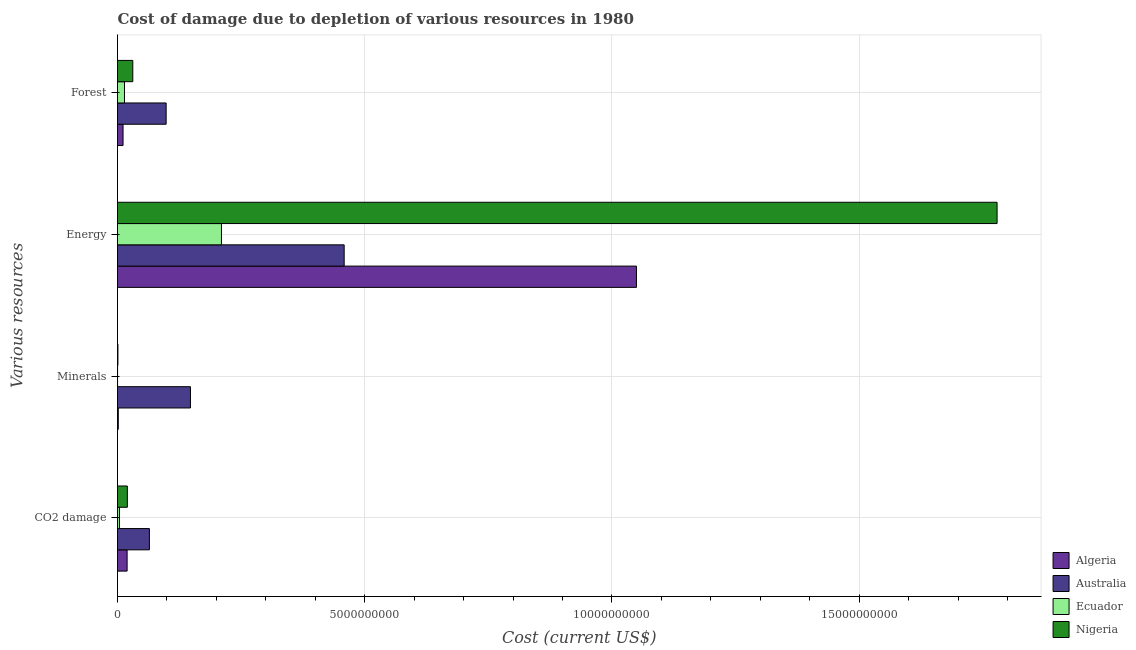How many bars are there on the 3rd tick from the bottom?
Offer a very short reply. 4. What is the label of the 2nd group of bars from the top?
Offer a very short reply. Energy. What is the cost of damage due to depletion of forests in Nigeria?
Keep it short and to the point. 3.09e+08. Across all countries, what is the maximum cost of damage due to depletion of forests?
Your answer should be very brief. 9.84e+08. Across all countries, what is the minimum cost of damage due to depletion of minerals?
Your response must be concise. 1.04e+06. In which country was the cost of damage due to depletion of energy maximum?
Ensure brevity in your answer.  Nigeria. In which country was the cost of damage due to depletion of energy minimum?
Give a very brief answer. Ecuador. What is the total cost of damage due to depletion of minerals in the graph?
Offer a very short reply. 1.50e+09. What is the difference between the cost of damage due to depletion of energy in Ecuador and that in Nigeria?
Your response must be concise. -1.57e+1. What is the difference between the cost of damage due to depletion of forests in Ecuador and the cost of damage due to depletion of minerals in Nigeria?
Provide a succinct answer. 1.33e+08. What is the average cost of damage due to depletion of minerals per country?
Ensure brevity in your answer.  3.75e+08. What is the difference between the cost of damage due to depletion of minerals and cost of damage due to depletion of energy in Nigeria?
Provide a succinct answer. -1.78e+1. What is the ratio of the cost of damage due to depletion of forests in Algeria to that in Ecuador?
Ensure brevity in your answer.  0.79. What is the difference between the highest and the second highest cost of damage due to depletion of forests?
Your answer should be compact. 6.75e+08. What is the difference between the highest and the lowest cost of damage due to depletion of forests?
Make the answer very short. 8.72e+08. Is it the case that in every country, the sum of the cost of damage due to depletion of forests and cost of damage due to depletion of energy is greater than the sum of cost of damage due to depletion of minerals and cost of damage due to depletion of coal?
Provide a short and direct response. No. What does the 2nd bar from the top in Forest represents?
Your answer should be compact. Ecuador. What does the 3rd bar from the bottom in Forest represents?
Provide a succinct answer. Ecuador. Is it the case that in every country, the sum of the cost of damage due to depletion of coal and cost of damage due to depletion of minerals is greater than the cost of damage due to depletion of energy?
Keep it short and to the point. No. Are all the bars in the graph horizontal?
Your answer should be compact. Yes. What is the difference between two consecutive major ticks on the X-axis?
Give a very brief answer. 5.00e+09. Are the values on the major ticks of X-axis written in scientific E-notation?
Ensure brevity in your answer.  No. Where does the legend appear in the graph?
Your answer should be very brief. Bottom right. How are the legend labels stacked?
Your response must be concise. Vertical. What is the title of the graph?
Offer a very short reply. Cost of damage due to depletion of various resources in 1980 . What is the label or title of the X-axis?
Provide a succinct answer. Cost (current US$). What is the label or title of the Y-axis?
Offer a terse response. Various resources. What is the Cost (current US$) in Algeria in CO2 damage?
Your answer should be very brief. 1.94e+08. What is the Cost (current US$) in Australia in CO2 damage?
Your answer should be very brief. 6.45e+08. What is the Cost (current US$) of Ecuador in CO2 damage?
Provide a short and direct response. 3.93e+07. What is the Cost (current US$) in Nigeria in CO2 damage?
Provide a succinct answer. 1.99e+08. What is the Cost (current US$) in Algeria in Minerals?
Provide a short and direct response. 1.57e+07. What is the Cost (current US$) of Australia in Minerals?
Provide a succinct answer. 1.48e+09. What is the Cost (current US$) of Ecuador in Minerals?
Ensure brevity in your answer.  1.04e+06. What is the Cost (current US$) in Nigeria in Minerals?
Your answer should be very brief. 8.49e+06. What is the Cost (current US$) of Algeria in Energy?
Your answer should be very brief. 1.05e+1. What is the Cost (current US$) in Australia in Energy?
Provide a short and direct response. 4.58e+09. What is the Cost (current US$) in Ecuador in Energy?
Your answer should be very brief. 2.10e+09. What is the Cost (current US$) in Nigeria in Energy?
Provide a succinct answer. 1.78e+1. What is the Cost (current US$) of Algeria in Forest?
Your answer should be very brief. 1.12e+08. What is the Cost (current US$) in Australia in Forest?
Ensure brevity in your answer.  9.84e+08. What is the Cost (current US$) of Ecuador in Forest?
Provide a short and direct response. 1.41e+08. What is the Cost (current US$) of Nigeria in Forest?
Provide a short and direct response. 3.09e+08. Across all Various resources, what is the maximum Cost (current US$) in Algeria?
Your answer should be compact. 1.05e+1. Across all Various resources, what is the maximum Cost (current US$) of Australia?
Offer a terse response. 4.58e+09. Across all Various resources, what is the maximum Cost (current US$) in Ecuador?
Keep it short and to the point. 2.10e+09. Across all Various resources, what is the maximum Cost (current US$) in Nigeria?
Your answer should be compact. 1.78e+1. Across all Various resources, what is the minimum Cost (current US$) in Algeria?
Keep it short and to the point. 1.57e+07. Across all Various resources, what is the minimum Cost (current US$) of Australia?
Ensure brevity in your answer.  6.45e+08. Across all Various resources, what is the minimum Cost (current US$) of Ecuador?
Your answer should be very brief. 1.04e+06. Across all Various resources, what is the minimum Cost (current US$) in Nigeria?
Provide a short and direct response. 8.49e+06. What is the total Cost (current US$) of Algeria in the graph?
Your answer should be compact. 1.08e+1. What is the total Cost (current US$) of Australia in the graph?
Offer a very short reply. 7.69e+09. What is the total Cost (current US$) in Ecuador in the graph?
Make the answer very short. 2.28e+09. What is the total Cost (current US$) of Nigeria in the graph?
Ensure brevity in your answer.  1.83e+1. What is the difference between the Cost (current US$) of Algeria in CO2 damage and that in Minerals?
Make the answer very short. 1.79e+08. What is the difference between the Cost (current US$) of Australia in CO2 damage and that in Minerals?
Your answer should be compact. -8.30e+08. What is the difference between the Cost (current US$) in Ecuador in CO2 damage and that in Minerals?
Offer a terse response. 3.82e+07. What is the difference between the Cost (current US$) in Nigeria in CO2 damage and that in Minerals?
Provide a short and direct response. 1.91e+08. What is the difference between the Cost (current US$) in Algeria in CO2 damage and that in Energy?
Ensure brevity in your answer.  -1.03e+1. What is the difference between the Cost (current US$) of Australia in CO2 damage and that in Energy?
Your answer should be very brief. -3.94e+09. What is the difference between the Cost (current US$) in Ecuador in CO2 damage and that in Energy?
Offer a terse response. -2.06e+09. What is the difference between the Cost (current US$) in Nigeria in CO2 damage and that in Energy?
Offer a very short reply. -1.76e+1. What is the difference between the Cost (current US$) of Algeria in CO2 damage and that in Forest?
Ensure brevity in your answer.  8.23e+07. What is the difference between the Cost (current US$) of Australia in CO2 damage and that in Forest?
Offer a very short reply. -3.39e+08. What is the difference between the Cost (current US$) in Ecuador in CO2 damage and that in Forest?
Give a very brief answer. -1.02e+08. What is the difference between the Cost (current US$) of Nigeria in CO2 damage and that in Forest?
Keep it short and to the point. -1.10e+08. What is the difference between the Cost (current US$) of Algeria in Minerals and that in Energy?
Offer a terse response. -1.05e+1. What is the difference between the Cost (current US$) in Australia in Minerals and that in Energy?
Ensure brevity in your answer.  -3.11e+09. What is the difference between the Cost (current US$) of Ecuador in Minerals and that in Energy?
Keep it short and to the point. -2.10e+09. What is the difference between the Cost (current US$) of Nigeria in Minerals and that in Energy?
Keep it short and to the point. -1.78e+1. What is the difference between the Cost (current US$) in Algeria in Minerals and that in Forest?
Provide a succinct answer. -9.63e+07. What is the difference between the Cost (current US$) in Australia in Minerals and that in Forest?
Provide a succinct answer. 4.92e+08. What is the difference between the Cost (current US$) in Ecuador in Minerals and that in Forest?
Provide a short and direct response. -1.40e+08. What is the difference between the Cost (current US$) of Nigeria in Minerals and that in Forest?
Your response must be concise. -3.01e+08. What is the difference between the Cost (current US$) in Algeria in Energy and that in Forest?
Keep it short and to the point. 1.04e+1. What is the difference between the Cost (current US$) of Australia in Energy and that in Forest?
Keep it short and to the point. 3.60e+09. What is the difference between the Cost (current US$) of Ecuador in Energy and that in Forest?
Provide a succinct answer. 1.96e+09. What is the difference between the Cost (current US$) of Nigeria in Energy and that in Forest?
Your response must be concise. 1.75e+1. What is the difference between the Cost (current US$) in Algeria in CO2 damage and the Cost (current US$) in Australia in Minerals?
Your answer should be very brief. -1.28e+09. What is the difference between the Cost (current US$) of Algeria in CO2 damage and the Cost (current US$) of Ecuador in Minerals?
Offer a terse response. 1.93e+08. What is the difference between the Cost (current US$) of Algeria in CO2 damage and the Cost (current US$) of Nigeria in Minerals?
Keep it short and to the point. 1.86e+08. What is the difference between the Cost (current US$) of Australia in CO2 damage and the Cost (current US$) of Ecuador in Minerals?
Provide a short and direct response. 6.44e+08. What is the difference between the Cost (current US$) in Australia in CO2 damage and the Cost (current US$) in Nigeria in Minerals?
Ensure brevity in your answer.  6.37e+08. What is the difference between the Cost (current US$) in Ecuador in CO2 damage and the Cost (current US$) in Nigeria in Minerals?
Your answer should be very brief. 3.08e+07. What is the difference between the Cost (current US$) of Algeria in CO2 damage and the Cost (current US$) of Australia in Energy?
Offer a very short reply. -4.39e+09. What is the difference between the Cost (current US$) in Algeria in CO2 damage and the Cost (current US$) in Ecuador in Energy?
Make the answer very short. -1.91e+09. What is the difference between the Cost (current US$) in Algeria in CO2 damage and the Cost (current US$) in Nigeria in Energy?
Your response must be concise. -1.76e+1. What is the difference between the Cost (current US$) of Australia in CO2 damage and the Cost (current US$) of Ecuador in Energy?
Provide a short and direct response. -1.46e+09. What is the difference between the Cost (current US$) in Australia in CO2 damage and the Cost (current US$) in Nigeria in Energy?
Provide a succinct answer. -1.71e+1. What is the difference between the Cost (current US$) of Ecuador in CO2 damage and the Cost (current US$) of Nigeria in Energy?
Make the answer very short. -1.77e+1. What is the difference between the Cost (current US$) in Algeria in CO2 damage and the Cost (current US$) in Australia in Forest?
Your response must be concise. -7.89e+08. What is the difference between the Cost (current US$) in Algeria in CO2 damage and the Cost (current US$) in Ecuador in Forest?
Your answer should be very brief. 5.31e+07. What is the difference between the Cost (current US$) in Algeria in CO2 damage and the Cost (current US$) in Nigeria in Forest?
Make the answer very short. -1.15e+08. What is the difference between the Cost (current US$) of Australia in CO2 damage and the Cost (current US$) of Ecuador in Forest?
Offer a very short reply. 5.04e+08. What is the difference between the Cost (current US$) of Australia in CO2 damage and the Cost (current US$) of Nigeria in Forest?
Provide a short and direct response. 3.36e+08. What is the difference between the Cost (current US$) in Ecuador in CO2 damage and the Cost (current US$) in Nigeria in Forest?
Make the answer very short. -2.70e+08. What is the difference between the Cost (current US$) in Algeria in Minerals and the Cost (current US$) in Australia in Energy?
Your answer should be very brief. -4.57e+09. What is the difference between the Cost (current US$) of Algeria in Minerals and the Cost (current US$) of Ecuador in Energy?
Keep it short and to the point. -2.09e+09. What is the difference between the Cost (current US$) of Algeria in Minerals and the Cost (current US$) of Nigeria in Energy?
Provide a short and direct response. -1.78e+1. What is the difference between the Cost (current US$) of Australia in Minerals and the Cost (current US$) of Ecuador in Energy?
Your answer should be compact. -6.27e+08. What is the difference between the Cost (current US$) of Australia in Minerals and the Cost (current US$) of Nigeria in Energy?
Make the answer very short. -1.63e+1. What is the difference between the Cost (current US$) in Ecuador in Minerals and the Cost (current US$) in Nigeria in Energy?
Keep it short and to the point. -1.78e+1. What is the difference between the Cost (current US$) in Algeria in Minerals and the Cost (current US$) in Australia in Forest?
Ensure brevity in your answer.  -9.68e+08. What is the difference between the Cost (current US$) of Algeria in Minerals and the Cost (current US$) of Ecuador in Forest?
Give a very brief answer. -1.26e+08. What is the difference between the Cost (current US$) in Algeria in Minerals and the Cost (current US$) in Nigeria in Forest?
Give a very brief answer. -2.93e+08. What is the difference between the Cost (current US$) in Australia in Minerals and the Cost (current US$) in Ecuador in Forest?
Ensure brevity in your answer.  1.33e+09. What is the difference between the Cost (current US$) of Australia in Minerals and the Cost (current US$) of Nigeria in Forest?
Provide a short and direct response. 1.17e+09. What is the difference between the Cost (current US$) in Ecuador in Minerals and the Cost (current US$) in Nigeria in Forest?
Give a very brief answer. -3.08e+08. What is the difference between the Cost (current US$) in Algeria in Energy and the Cost (current US$) in Australia in Forest?
Your answer should be compact. 9.51e+09. What is the difference between the Cost (current US$) in Algeria in Energy and the Cost (current US$) in Ecuador in Forest?
Your answer should be compact. 1.04e+1. What is the difference between the Cost (current US$) of Algeria in Energy and the Cost (current US$) of Nigeria in Forest?
Provide a succinct answer. 1.02e+1. What is the difference between the Cost (current US$) of Australia in Energy and the Cost (current US$) of Ecuador in Forest?
Make the answer very short. 4.44e+09. What is the difference between the Cost (current US$) in Australia in Energy and the Cost (current US$) in Nigeria in Forest?
Give a very brief answer. 4.28e+09. What is the difference between the Cost (current US$) in Ecuador in Energy and the Cost (current US$) in Nigeria in Forest?
Give a very brief answer. 1.79e+09. What is the average Cost (current US$) in Algeria per Various resources?
Provide a short and direct response. 2.70e+09. What is the average Cost (current US$) in Australia per Various resources?
Ensure brevity in your answer.  1.92e+09. What is the average Cost (current US$) in Ecuador per Various resources?
Your answer should be compact. 5.71e+08. What is the average Cost (current US$) in Nigeria per Various resources?
Offer a terse response. 4.58e+09. What is the difference between the Cost (current US$) of Algeria and Cost (current US$) of Australia in CO2 damage?
Provide a succinct answer. -4.51e+08. What is the difference between the Cost (current US$) of Algeria and Cost (current US$) of Ecuador in CO2 damage?
Provide a short and direct response. 1.55e+08. What is the difference between the Cost (current US$) of Algeria and Cost (current US$) of Nigeria in CO2 damage?
Make the answer very short. -4.78e+06. What is the difference between the Cost (current US$) in Australia and Cost (current US$) in Ecuador in CO2 damage?
Keep it short and to the point. 6.06e+08. What is the difference between the Cost (current US$) in Australia and Cost (current US$) in Nigeria in CO2 damage?
Provide a succinct answer. 4.46e+08. What is the difference between the Cost (current US$) in Ecuador and Cost (current US$) in Nigeria in CO2 damage?
Your answer should be compact. -1.60e+08. What is the difference between the Cost (current US$) of Algeria and Cost (current US$) of Australia in Minerals?
Offer a terse response. -1.46e+09. What is the difference between the Cost (current US$) in Algeria and Cost (current US$) in Ecuador in Minerals?
Offer a very short reply. 1.47e+07. What is the difference between the Cost (current US$) in Algeria and Cost (current US$) in Nigeria in Minerals?
Your answer should be very brief. 7.25e+06. What is the difference between the Cost (current US$) of Australia and Cost (current US$) of Ecuador in Minerals?
Offer a terse response. 1.47e+09. What is the difference between the Cost (current US$) of Australia and Cost (current US$) of Nigeria in Minerals?
Provide a short and direct response. 1.47e+09. What is the difference between the Cost (current US$) of Ecuador and Cost (current US$) of Nigeria in Minerals?
Give a very brief answer. -7.45e+06. What is the difference between the Cost (current US$) of Algeria and Cost (current US$) of Australia in Energy?
Keep it short and to the point. 5.91e+09. What is the difference between the Cost (current US$) of Algeria and Cost (current US$) of Ecuador in Energy?
Your answer should be compact. 8.39e+09. What is the difference between the Cost (current US$) in Algeria and Cost (current US$) in Nigeria in Energy?
Your answer should be very brief. -7.29e+09. What is the difference between the Cost (current US$) in Australia and Cost (current US$) in Ecuador in Energy?
Provide a succinct answer. 2.48e+09. What is the difference between the Cost (current US$) of Australia and Cost (current US$) of Nigeria in Energy?
Give a very brief answer. -1.32e+1. What is the difference between the Cost (current US$) of Ecuador and Cost (current US$) of Nigeria in Energy?
Keep it short and to the point. -1.57e+1. What is the difference between the Cost (current US$) of Algeria and Cost (current US$) of Australia in Forest?
Offer a very short reply. -8.72e+08. What is the difference between the Cost (current US$) of Algeria and Cost (current US$) of Ecuador in Forest?
Your answer should be compact. -2.92e+07. What is the difference between the Cost (current US$) in Algeria and Cost (current US$) in Nigeria in Forest?
Keep it short and to the point. -1.97e+08. What is the difference between the Cost (current US$) in Australia and Cost (current US$) in Ecuador in Forest?
Provide a succinct answer. 8.42e+08. What is the difference between the Cost (current US$) in Australia and Cost (current US$) in Nigeria in Forest?
Give a very brief answer. 6.75e+08. What is the difference between the Cost (current US$) in Ecuador and Cost (current US$) in Nigeria in Forest?
Provide a succinct answer. -1.68e+08. What is the ratio of the Cost (current US$) of Algeria in CO2 damage to that in Minerals?
Provide a short and direct response. 12.35. What is the ratio of the Cost (current US$) of Australia in CO2 damage to that in Minerals?
Offer a very short reply. 0.44. What is the ratio of the Cost (current US$) of Ecuador in CO2 damage to that in Minerals?
Offer a very short reply. 37.63. What is the ratio of the Cost (current US$) of Nigeria in CO2 damage to that in Minerals?
Offer a very short reply. 23.45. What is the ratio of the Cost (current US$) in Algeria in CO2 damage to that in Energy?
Offer a very short reply. 0.02. What is the ratio of the Cost (current US$) of Australia in CO2 damage to that in Energy?
Make the answer very short. 0.14. What is the ratio of the Cost (current US$) of Ecuador in CO2 damage to that in Energy?
Your response must be concise. 0.02. What is the ratio of the Cost (current US$) in Nigeria in CO2 damage to that in Energy?
Your response must be concise. 0.01. What is the ratio of the Cost (current US$) of Algeria in CO2 damage to that in Forest?
Offer a very short reply. 1.73. What is the ratio of the Cost (current US$) in Australia in CO2 damage to that in Forest?
Your response must be concise. 0.66. What is the ratio of the Cost (current US$) of Ecuador in CO2 damage to that in Forest?
Your answer should be very brief. 0.28. What is the ratio of the Cost (current US$) in Nigeria in CO2 damage to that in Forest?
Give a very brief answer. 0.64. What is the ratio of the Cost (current US$) of Algeria in Minerals to that in Energy?
Your answer should be compact. 0. What is the ratio of the Cost (current US$) in Australia in Minerals to that in Energy?
Ensure brevity in your answer.  0.32. What is the ratio of the Cost (current US$) in Nigeria in Minerals to that in Energy?
Your answer should be very brief. 0. What is the ratio of the Cost (current US$) of Algeria in Minerals to that in Forest?
Ensure brevity in your answer.  0.14. What is the ratio of the Cost (current US$) of Australia in Minerals to that in Forest?
Provide a succinct answer. 1.5. What is the ratio of the Cost (current US$) in Ecuador in Minerals to that in Forest?
Your response must be concise. 0.01. What is the ratio of the Cost (current US$) of Nigeria in Minerals to that in Forest?
Provide a succinct answer. 0.03. What is the ratio of the Cost (current US$) in Algeria in Energy to that in Forest?
Provide a short and direct response. 93.67. What is the ratio of the Cost (current US$) in Australia in Energy to that in Forest?
Keep it short and to the point. 4.66. What is the ratio of the Cost (current US$) in Ecuador in Energy to that in Forest?
Provide a short and direct response. 14.88. What is the ratio of the Cost (current US$) of Nigeria in Energy to that in Forest?
Keep it short and to the point. 57.55. What is the difference between the highest and the second highest Cost (current US$) in Algeria?
Your answer should be compact. 1.03e+1. What is the difference between the highest and the second highest Cost (current US$) in Australia?
Your answer should be compact. 3.11e+09. What is the difference between the highest and the second highest Cost (current US$) of Ecuador?
Your response must be concise. 1.96e+09. What is the difference between the highest and the second highest Cost (current US$) in Nigeria?
Offer a very short reply. 1.75e+1. What is the difference between the highest and the lowest Cost (current US$) in Algeria?
Provide a short and direct response. 1.05e+1. What is the difference between the highest and the lowest Cost (current US$) in Australia?
Give a very brief answer. 3.94e+09. What is the difference between the highest and the lowest Cost (current US$) of Ecuador?
Offer a terse response. 2.10e+09. What is the difference between the highest and the lowest Cost (current US$) of Nigeria?
Provide a short and direct response. 1.78e+1. 